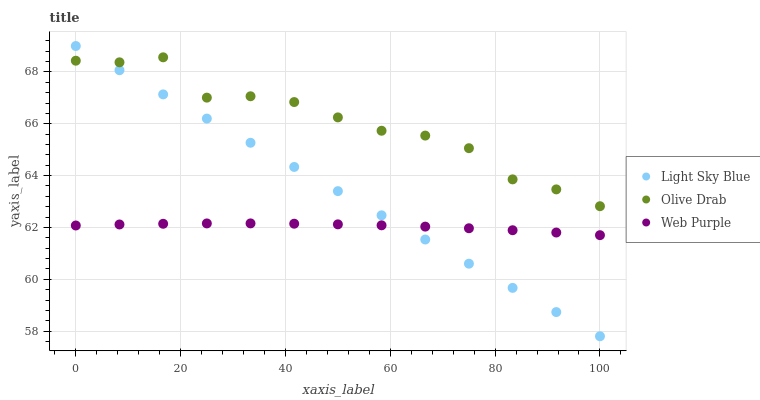Does Web Purple have the minimum area under the curve?
Answer yes or no. Yes. Does Olive Drab have the maximum area under the curve?
Answer yes or no. Yes. Does Light Sky Blue have the minimum area under the curve?
Answer yes or no. No. Does Light Sky Blue have the maximum area under the curve?
Answer yes or no. No. Is Light Sky Blue the smoothest?
Answer yes or no. Yes. Is Olive Drab the roughest?
Answer yes or no. Yes. Is Olive Drab the smoothest?
Answer yes or no. No. Is Light Sky Blue the roughest?
Answer yes or no. No. Does Light Sky Blue have the lowest value?
Answer yes or no. Yes. Does Olive Drab have the lowest value?
Answer yes or no. No. Does Light Sky Blue have the highest value?
Answer yes or no. Yes. Does Olive Drab have the highest value?
Answer yes or no. No. Is Web Purple less than Olive Drab?
Answer yes or no. Yes. Is Olive Drab greater than Web Purple?
Answer yes or no. Yes. Does Olive Drab intersect Light Sky Blue?
Answer yes or no. Yes. Is Olive Drab less than Light Sky Blue?
Answer yes or no. No. Is Olive Drab greater than Light Sky Blue?
Answer yes or no. No. Does Web Purple intersect Olive Drab?
Answer yes or no. No. 